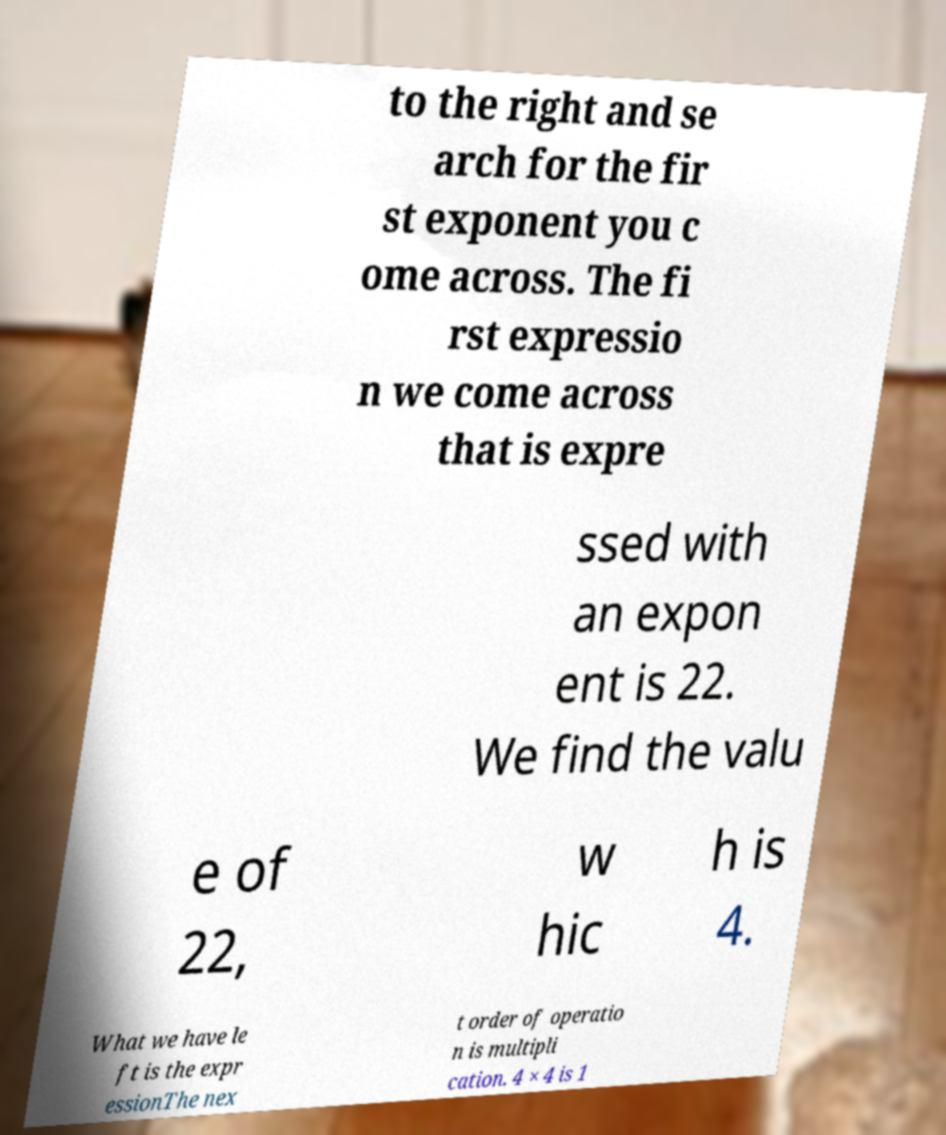For documentation purposes, I need the text within this image transcribed. Could you provide that? to the right and se arch for the fir st exponent you c ome across. The fi rst expressio n we come across that is expre ssed with an expon ent is 22. We find the valu e of 22, w hic h is 4. What we have le ft is the expr essionThe nex t order of operatio n is multipli cation. 4 × 4 is 1 